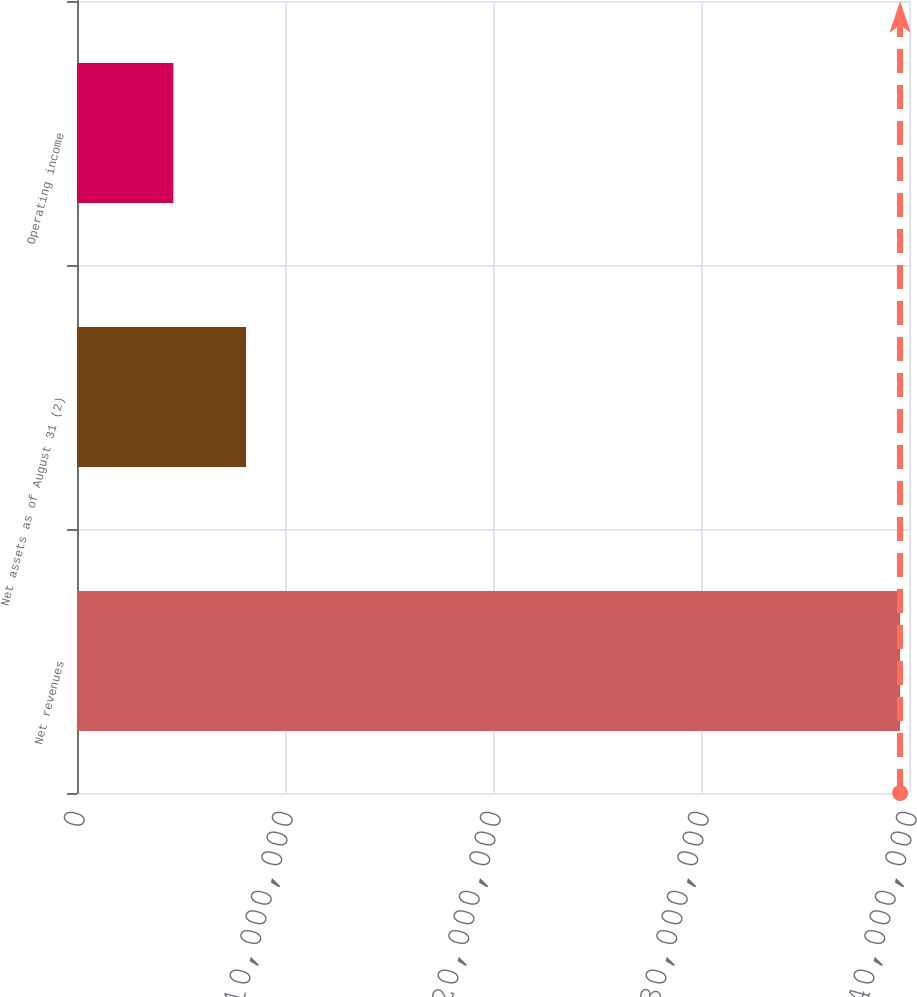<chart> <loc_0><loc_0><loc_500><loc_500><bar_chart><fcel>Net revenues<fcel>Net assets as of August 31 (2)<fcel>Operating income<nl><fcel>3.95734e+07<fcel>8.12669e+06<fcel>4.63261e+06<nl></chart> 